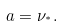<formula> <loc_0><loc_0><loc_500><loc_500>a = \nu _ { ^ { * } } .</formula> 